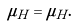Convert formula to latex. <formula><loc_0><loc_0><loc_500><loc_500>\mu _ { H } = \mu _ { \tilde { H } } .</formula> 